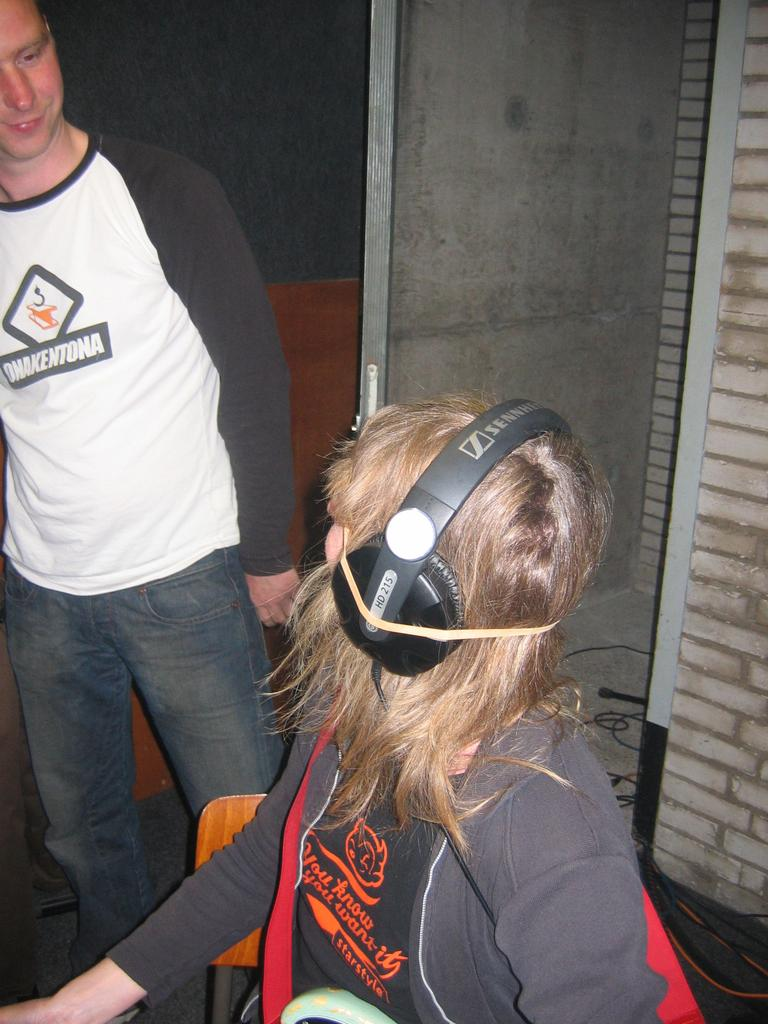What is the person in the image wearing? The person is wearing a jacket in the image. What is the person using to communicate or listen in the image? The person is wearing a headset in the image. What is the person's position in the image? The person is sitting on a chair in the image. Who is the person looking at in the image? The person is looking at a man standing on the left side in the image. What can be seen in the background of the image? There is a door visible in the background of the image. Where is the door located in the image? The door is on a wall in the image. Can you tell me how many goats are visible in the image? There are no goats present in the image. What type of waste is being disposed of in the image? There is no waste being disposed of in the image. 